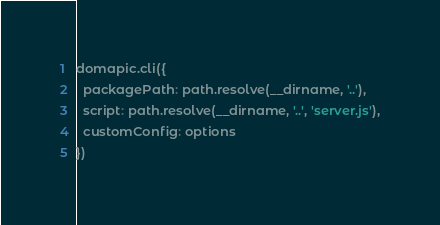<code> <loc_0><loc_0><loc_500><loc_500><_JavaScript_>domapic.cli({
  packagePath: path.resolve(__dirname, '..'),
  script: path.resolve(__dirname, '..', 'server.js'),
  customConfig: options
})
</code> 